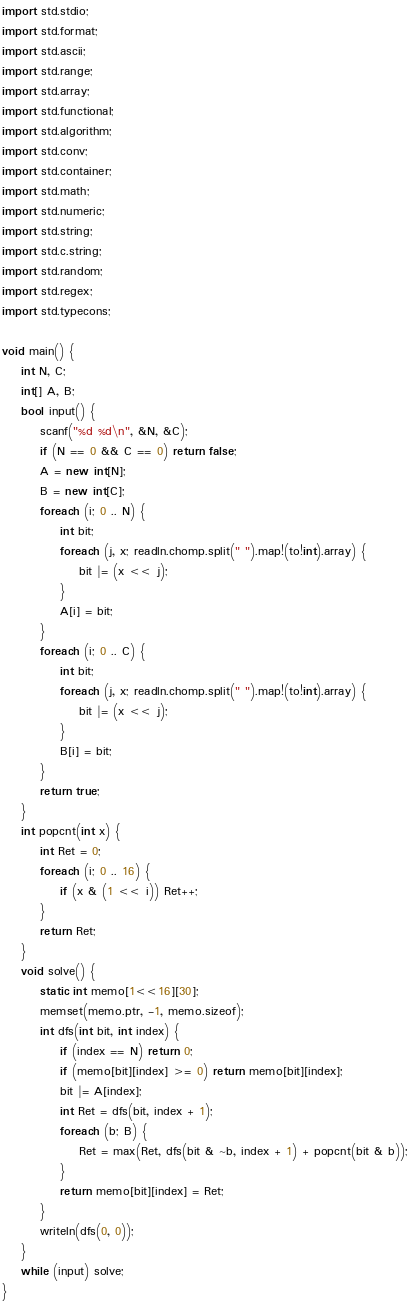Convert code to text. <code><loc_0><loc_0><loc_500><loc_500><_D_>import std.stdio;
import std.format;
import std.ascii;
import std.range;
import std.array;
import std.functional;
import std.algorithm;
import std.conv;
import std.container;
import std.math;
import std.numeric;
import std.string;
import std.c.string;
import std.random;
import std.regex;
import std.typecons;

void main() {
    int N, C;
    int[] A, B;
    bool input() {
        scanf("%d %d\n", &N, &C);
        if (N == 0 && C == 0) return false;
        A = new int[N];
        B = new int[C];
        foreach (i; 0 .. N) {
            int bit;
            foreach (j, x; readln.chomp.split(" ").map!(to!int).array) {
                bit |= (x << j);
            }
            A[i] = bit;
        }
        foreach (i; 0 .. C) {
            int bit;
            foreach (j, x; readln.chomp.split(" ").map!(to!int).array) {
                bit |= (x << j);
            }
            B[i] = bit;
        }
        return true;
    }
    int popcnt(int x) {
        int Ret = 0;
        foreach (i; 0 .. 16) {
            if (x & (1 << i)) Ret++;
        }
        return Ret;
    }
    void solve() {
        static int memo[1<<16][30];
        memset(memo.ptr, -1, memo.sizeof);
        int dfs(int bit, int index) {
            if (index == N) return 0;
            if (memo[bit][index] >= 0) return memo[bit][index];
            bit |= A[index];
            int Ret = dfs(bit, index + 1);
            foreach (b; B) {
                Ret = max(Ret, dfs(bit & ~b, index + 1) + popcnt(bit & b));
            }
            return memo[bit][index] = Ret;
        }
        writeln(dfs(0, 0));
    }
    while (input) solve;
}</code> 